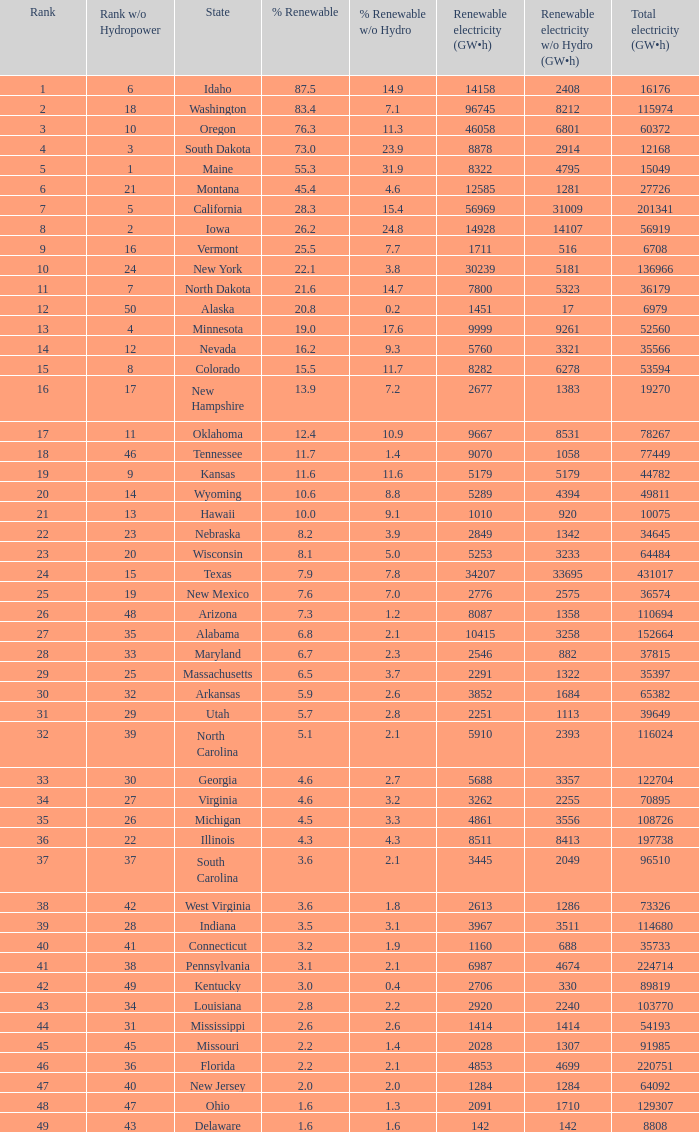Which state has 5179 (gw×h) of renewable energy without hydrogen power?wha Kansas. 